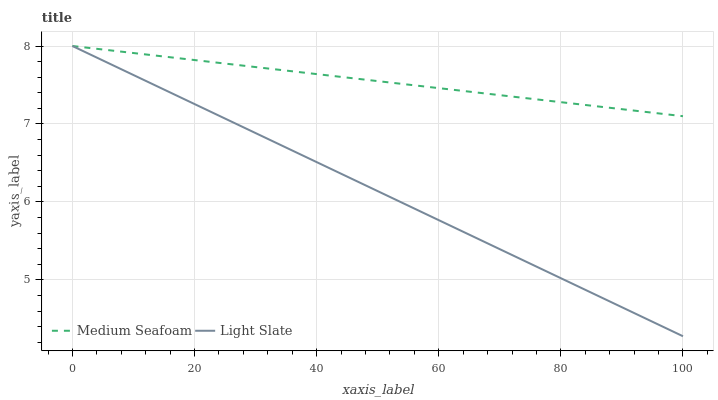Does Light Slate have the minimum area under the curve?
Answer yes or no. Yes. Does Medium Seafoam have the maximum area under the curve?
Answer yes or no. Yes. Does Medium Seafoam have the minimum area under the curve?
Answer yes or no. No. Is Light Slate the smoothest?
Answer yes or no. Yes. Is Medium Seafoam the roughest?
Answer yes or no. Yes. Is Medium Seafoam the smoothest?
Answer yes or no. No. Does Light Slate have the lowest value?
Answer yes or no. Yes. Does Medium Seafoam have the lowest value?
Answer yes or no. No. Does Medium Seafoam have the highest value?
Answer yes or no. Yes. Does Light Slate intersect Medium Seafoam?
Answer yes or no. Yes. Is Light Slate less than Medium Seafoam?
Answer yes or no. No. Is Light Slate greater than Medium Seafoam?
Answer yes or no. No. 